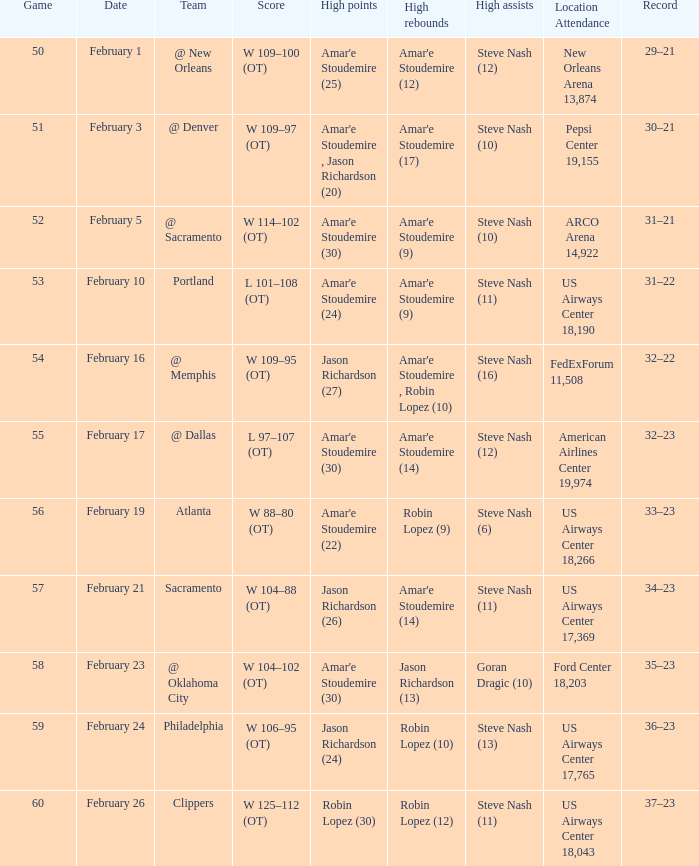List the top experiences at pepsi center 19,15 Amar'e Stoudemire , Jason Richardson (20). 